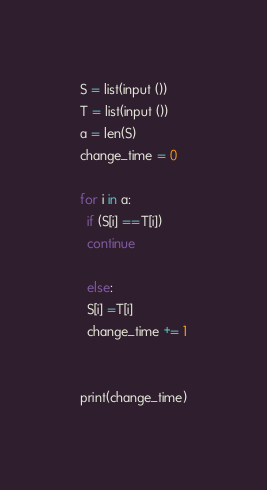Convert code to text. <code><loc_0><loc_0><loc_500><loc_500><_Python_>S = list(input ())
T = list(input ())
a = len(S)
change_time = 0

for i in a:
  if (S[i] ==T[i])
  continue
  
  else:
  S[i] =T[i]
  change_time += 1
  
  
print(change_time)</code> 